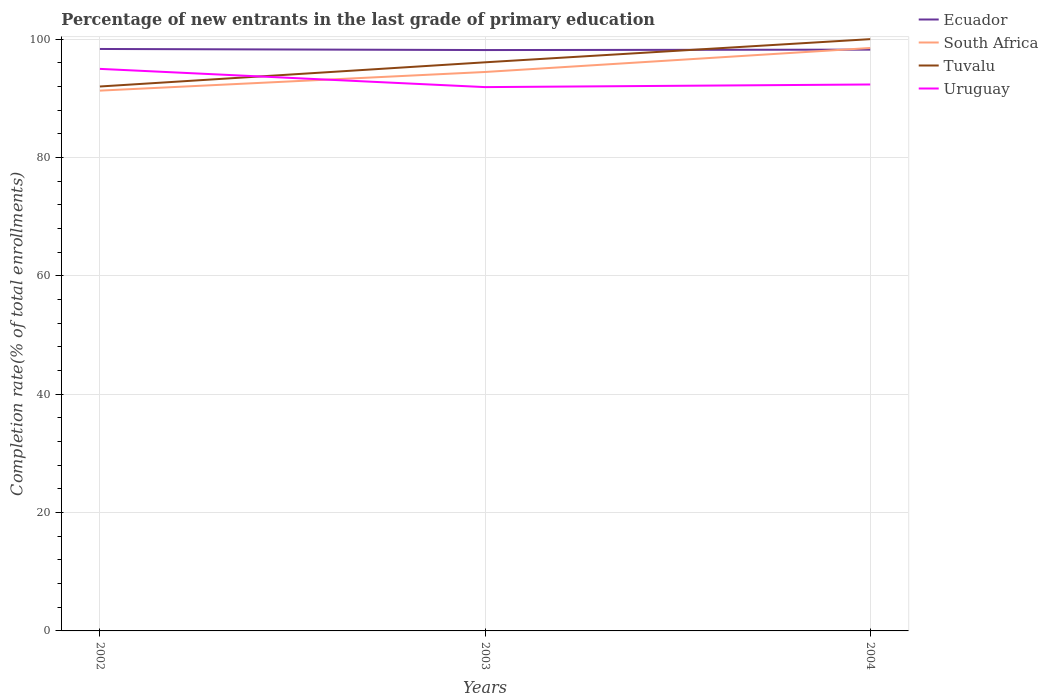Does the line corresponding to Ecuador intersect with the line corresponding to Uruguay?
Provide a succinct answer. No. Is the number of lines equal to the number of legend labels?
Your response must be concise. Yes. Across all years, what is the maximum percentage of new entrants in Uruguay?
Keep it short and to the point. 91.9. What is the total percentage of new entrants in Ecuador in the graph?
Your answer should be compact. 0.18. What is the difference between the highest and the second highest percentage of new entrants in Ecuador?
Keep it short and to the point. 0.18. What is the difference between the highest and the lowest percentage of new entrants in Uruguay?
Give a very brief answer. 1. How many lines are there?
Keep it short and to the point. 4. How many years are there in the graph?
Provide a succinct answer. 3. Are the values on the major ticks of Y-axis written in scientific E-notation?
Your answer should be very brief. No. Where does the legend appear in the graph?
Make the answer very short. Top right. What is the title of the graph?
Make the answer very short. Percentage of new entrants in the last grade of primary education. What is the label or title of the X-axis?
Provide a short and direct response. Years. What is the label or title of the Y-axis?
Offer a very short reply. Completion rate(% of total enrollments). What is the Completion rate(% of total enrollments) of Ecuador in 2002?
Provide a short and direct response. 98.34. What is the Completion rate(% of total enrollments) of South Africa in 2002?
Keep it short and to the point. 91.3. What is the Completion rate(% of total enrollments) in Tuvalu in 2002?
Provide a succinct answer. 92. What is the Completion rate(% of total enrollments) in Uruguay in 2002?
Keep it short and to the point. 94.98. What is the Completion rate(% of total enrollments) in Ecuador in 2003?
Your answer should be compact. 98.16. What is the Completion rate(% of total enrollments) of South Africa in 2003?
Keep it short and to the point. 94.45. What is the Completion rate(% of total enrollments) of Tuvalu in 2003?
Make the answer very short. 96.09. What is the Completion rate(% of total enrollments) of Uruguay in 2003?
Offer a terse response. 91.9. What is the Completion rate(% of total enrollments) of Ecuador in 2004?
Ensure brevity in your answer.  98.23. What is the Completion rate(% of total enrollments) of South Africa in 2004?
Give a very brief answer. 98.51. What is the Completion rate(% of total enrollments) of Uruguay in 2004?
Offer a very short reply. 92.34. Across all years, what is the maximum Completion rate(% of total enrollments) of Ecuador?
Your answer should be very brief. 98.34. Across all years, what is the maximum Completion rate(% of total enrollments) of South Africa?
Provide a succinct answer. 98.51. Across all years, what is the maximum Completion rate(% of total enrollments) of Uruguay?
Offer a terse response. 94.98. Across all years, what is the minimum Completion rate(% of total enrollments) in Ecuador?
Provide a short and direct response. 98.16. Across all years, what is the minimum Completion rate(% of total enrollments) of South Africa?
Provide a succinct answer. 91.3. Across all years, what is the minimum Completion rate(% of total enrollments) in Tuvalu?
Keep it short and to the point. 92. Across all years, what is the minimum Completion rate(% of total enrollments) in Uruguay?
Provide a short and direct response. 91.9. What is the total Completion rate(% of total enrollments) in Ecuador in the graph?
Make the answer very short. 294.73. What is the total Completion rate(% of total enrollments) of South Africa in the graph?
Your answer should be compact. 284.26. What is the total Completion rate(% of total enrollments) of Tuvalu in the graph?
Keep it short and to the point. 288.09. What is the total Completion rate(% of total enrollments) of Uruguay in the graph?
Keep it short and to the point. 279.21. What is the difference between the Completion rate(% of total enrollments) in Ecuador in 2002 and that in 2003?
Keep it short and to the point. 0.18. What is the difference between the Completion rate(% of total enrollments) in South Africa in 2002 and that in 2003?
Keep it short and to the point. -3.15. What is the difference between the Completion rate(% of total enrollments) of Tuvalu in 2002 and that in 2003?
Make the answer very short. -4.09. What is the difference between the Completion rate(% of total enrollments) of Uruguay in 2002 and that in 2003?
Your answer should be compact. 3.08. What is the difference between the Completion rate(% of total enrollments) in Ecuador in 2002 and that in 2004?
Ensure brevity in your answer.  0.11. What is the difference between the Completion rate(% of total enrollments) of South Africa in 2002 and that in 2004?
Your answer should be very brief. -7.21. What is the difference between the Completion rate(% of total enrollments) in Uruguay in 2002 and that in 2004?
Ensure brevity in your answer.  2.64. What is the difference between the Completion rate(% of total enrollments) of Ecuador in 2003 and that in 2004?
Offer a terse response. -0.07. What is the difference between the Completion rate(% of total enrollments) in South Africa in 2003 and that in 2004?
Provide a short and direct response. -4.06. What is the difference between the Completion rate(% of total enrollments) of Tuvalu in 2003 and that in 2004?
Your response must be concise. -3.91. What is the difference between the Completion rate(% of total enrollments) of Uruguay in 2003 and that in 2004?
Ensure brevity in your answer.  -0.44. What is the difference between the Completion rate(% of total enrollments) of Ecuador in 2002 and the Completion rate(% of total enrollments) of South Africa in 2003?
Keep it short and to the point. 3.89. What is the difference between the Completion rate(% of total enrollments) of Ecuador in 2002 and the Completion rate(% of total enrollments) of Tuvalu in 2003?
Ensure brevity in your answer.  2.25. What is the difference between the Completion rate(% of total enrollments) of Ecuador in 2002 and the Completion rate(% of total enrollments) of Uruguay in 2003?
Keep it short and to the point. 6.44. What is the difference between the Completion rate(% of total enrollments) in South Africa in 2002 and the Completion rate(% of total enrollments) in Tuvalu in 2003?
Provide a short and direct response. -4.79. What is the difference between the Completion rate(% of total enrollments) in South Africa in 2002 and the Completion rate(% of total enrollments) in Uruguay in 2003?
Ensure brevity in your answer.  -0.6. What is the difference between the Completion rate(% of total enrollments) in Tuvalu in 2002 and the Completion rate(% of total enrollments) in Uruguay in 2003?
Your answer should be very brief. 0.1. What is the difference between the Completion rate(% of total enrollments) in Ecuador in 2002 and the Completion rate(% of total enrollments) in South Africa in 2004?
Offer a terse response. -0.17. What is the difference between the Completion rate(% of total enrollments) in Ecuador in 2002 and the Completion rate(% of total enrollments) in Tuvalu in 2004?
Give a very brief answer. -1.66. What is the difference between the Completion rate(% of total enrollments) of Ecuador in 2002 and the Completion rate(% of total enrollments) of Uruguay in 2004?
Keep it short and to the point. 6. What is the difference between the Completion rate(% of total enrollments) in South Africa in 2002 and the Completion rate(% of total enrollments) in Tuvalu in 2004?
Keep it short and to the point. -8.7. What is the difference between the Completion rate(% of total enrollments) of South Africa in 2002 and the Completion rate(% of total enrollments) of Uruguay in 2004?
Ensure brevity in your answer.  -1.04. What is the difference between the Completion rate(% of total enrollments) in Tuvalu in 2002 and the Completion rate(% of total enrollments) in Uruguay in 2004?
Your answer should be compact. -0.34. What is the difference between the Completion rate(% of total enrollments) of Ecuador in 2003 and the Completion rate(% of total enrollments) of South Africa in 2004?
Provide a succinct answer. -0.35. What is the difference between the Completion rate(% of total enrollments) of Ecuador in 2003 and the Completion rate(% of total enrollments) of Tuvalu in 2004?
Provide a short and direct response. -1.84. What is the difference between the Completion rate(% of total enrollments) in Ecuador in 2003 and the Completion rate(% of total enrollments) in Uruguay in 2004?
Your answer should be very brief. 5.82. What is the difference between the Completion rate(% of total enrollments) in South Africa in 2003 and the Completion rate(% of total enrollments) in Tuvalu in 2004?
Ensure brevity in your answer.  -5.55. What is the difference between the Completion rate(% of total enrollments) in South Africa in 2003 and the Completion rate(% of total enrollments) in Uruguay in 2004?
Offer a terse response. 2.11. What is the difference between the Completion rate(% of total enrollments) of Tuvalu in 2003 and the Completion rate(% of total enrollments) of Uruguay in 2004?
Keep it short and to the point. 3.75. What is the average Completion rate(% of total enrollments) in Ecuador per year?
Give a very brief answer. 98.24. What is the average Completion rate(% of total enrollments) in South Africa per year?
Make the answer very short. 94.75. What is the average Completion rate(% of total enrollments) in Tuvalu per year?
Provide a short and direct response. 96.03. What is the average Completion rate(% of total enrollments) in Uruguay per year?
Ensure brevity in your answer.  93.07. In the year 2002, what is the difference between the Completion rate(% of total enrollments) of Ecuador and Completion rate(% of total enrollments) of South Africa?
Provide a succinct answer. 7.04. In the year 2002, what is the difference between the Completion rate(% of total enrollments) in Ecuador and Completion rate(% of total enrollments) in Tuvalu?
Provide a short and direct response. 6.34. In the year 2002, what is the difference between the Completion rate(% of total enrollments) of Ecuador and Completion rate(% of total enrollments) of Uruguay?
Your answer should be very brief. 3.36. In the year 2002, what is the difference between the Completion rate(% of total enrollments) in South Africa and Completion rate(% of total enrollments) in Tuvalu?
Provide a short and direct response. -0.7. In the year 2002, what is the difference between the Completion rate(% of total enrollments) in South Africa and Completion rate(% of total enrollments) in Uruguay?
Give a very brief answer. -3.68. In the year 2002, what is the difference between the Completion rate(% of total enrollments) in Tuvalu and Completion rate(% of total enrollments) in Uruguay?
Your answer should be very brief. -2.98. In the year 2003, what is the difference between the Completion rate(% of total enrollments) of Ecuador and Completion rate(% of total enrollments) of South Africa?
Offer a very short reply. 3.71. In the year 2003, what is the difference between the Completion rate(% of total enrollments) in Ecuador and Completion rate(% of total enrollments) in Tuvalu?
Ensure brevity in your answer.  2.07. In the year 2003, what is the difference between the Completion rate(% of total enrollments) in Ecuador and Completion rate(% of total enrollments) in Uruguay?
Give a very brief answer. 6.26. In the year 2003, what is the difference between the Completion rate(% of total enrollments) of South Africa and Completion rate(% of total enrollments) of Tuvalu?
Keep it short and to the point. -1.64. In the year 2003, what is the difference between the Completion rate(% of total enrollments) in South Africa and Completion rate(% of total enrollments) in Uruguay?
Provide a succinct answer. 2.55. In the year 2003, what is the difference between the Completion rate(% of total enrollments) in Tuvalu and Completion rate(% of total enrollments) in Uruguay?
Offer a very short reply. 4.19. In the year 2004, what is the difference between the Completion rate(% of total enrollments) of Ecuador and Completion rate(% of total enrollments) of South Africa?
Your response must be concise. -0.28. In the year 2004, what is the difference between the Completion rate(% of total enrollments) in Ecuador and Completion rate(% of total enrollments) in Tuvalu?
Give a very brief answer. -1.77. In the year 2004, what is the difference between the Completion rate(% of total enrollments) of Ecuador and Completion rate(% of total enrollments) of Uruguay?
Offer a very short reply. 5.89. In the year 2004, what is the difference between the Completion rate(% of total enrollments) of South Africa and Completion rate(% of total enrollments) of Tuvalu?
Provide a short and direct response. -1.49. In the year 2004, what is the difference between the Completion rate(% of total enrollments) of South Africa and Completion rate(% of total enrollments) of Uruguay?
Your answer should be compact. 6.17. In the year 2004, what is the difference between the Completion rate(% of total enrollments) in Tuvalu and Completion rate(% of total enrollments) in Uruguay?
Give a very brief answer. 7.66. What is the ratio of the Completion rate(% of total enrollments) of South Africa in 2002 to that in 2003?
Offer a terse response. 0.97. What is the ratio of the Completion rate(% of total enrollments) in Tuvalu in 2002 to that in 2003?
Provide a succinct answer. 0.96. What is the ratio of the Completion rate(% of total enrollments) in Uruguay in 2002 to that in 2003?
Keep it short and to the point. 1.03. What is the ratio of the Completion rate(% of total enrollments) of Ecuador in 2002 to that in 2004?
Offer a terse response. 1. What is the ratio of the Completion rate(% of total enrollments) in South Africa in 2002 to that in 2004?
Offer a very short reply. 0.93. What is the ratio of the Completion rate(% of total enrollments) of Tuvalu in 2002 to that in 2004?
Your answer should be compact. 0.92. What is the ratio of the Completion rate(% of total enrollments) of Uruguay in 2002 to that in 2004?
Your answer should be compact. 1.03. What is the ratio of the Completion rate(% of total enrollments) of Ecuador in 2003 to that in 2004?
Your answer should be very brief. 1. What is the ratio of the Completion rate(% of total enrollments) of South Africa in 2003 to that in 2004?
Give a very brief answer. 0.96. What is the ratio of the Completion rate(% of total enrollments) of Tuvalu in 2003 to that in 2004?
Your answer should be very brief. 0.96. What is the difference between the highest and the second highest Completion rate(% of total enrollments) in Ecuador?
Give a very brief answer. 0.11. What is the difference between the highest and the second highest Completion rate(% of total enrollments) of South Africa?
Offer a terse response. 4.06. What is the difference between the highest and the second highest Completion rate(% of total enrollments) of Tuvalu?
Make the answer very short. 3.91. What is the difference between the highest and the second highest Completion rate(% of total enrollments) of Uruguay?
Your answer should be compact. 2.64. What is the difference between the highest and the lowest Completion rate(% of total enrollments) in Ecuador?
Provide a short and direct response. 0.18. What is the difference between the highest and the lowest Completion rate(% of total enrollments) in South Africa?
Your answer should be very brief. 7.21. What is the difference between the highest and the lowest Completion rate(% of total enrollments) in Tuvalu?
Make the answer very short. 8. What is the difference between the highest and the lowest Completion rate(% of total enrollments) of Uruguay?
Offer a terse response. 3.08. 